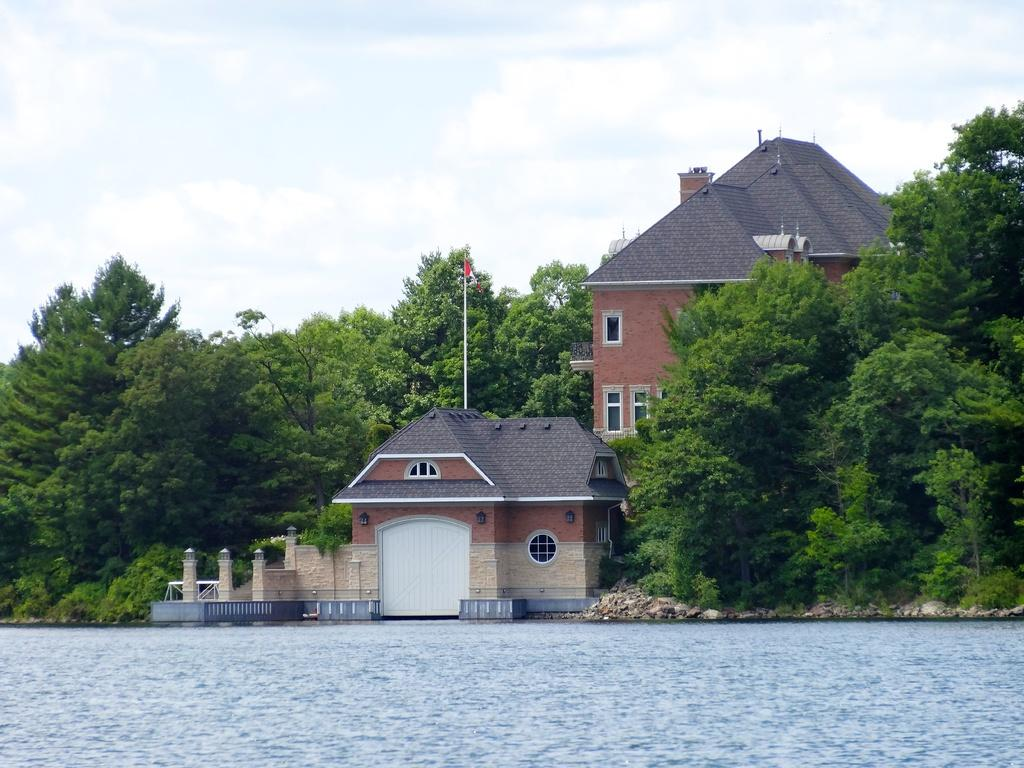What is present at the bottom of the image? There is water at the bottom of the image. What can be seen in the middle of the image? There are buildings, trees, and poles in the middle of the image. What is visible at the top of the image? There are clouds and the sky visible at the top of the image. How many keys are hanging from the trees in the image? There are no keys present in the image; it features buildings, trees, and poles. What type of pollution can be seen in the image? There is no pollution visible in the image; it features water, buildings, trees, poles, clouds, and the sky. 